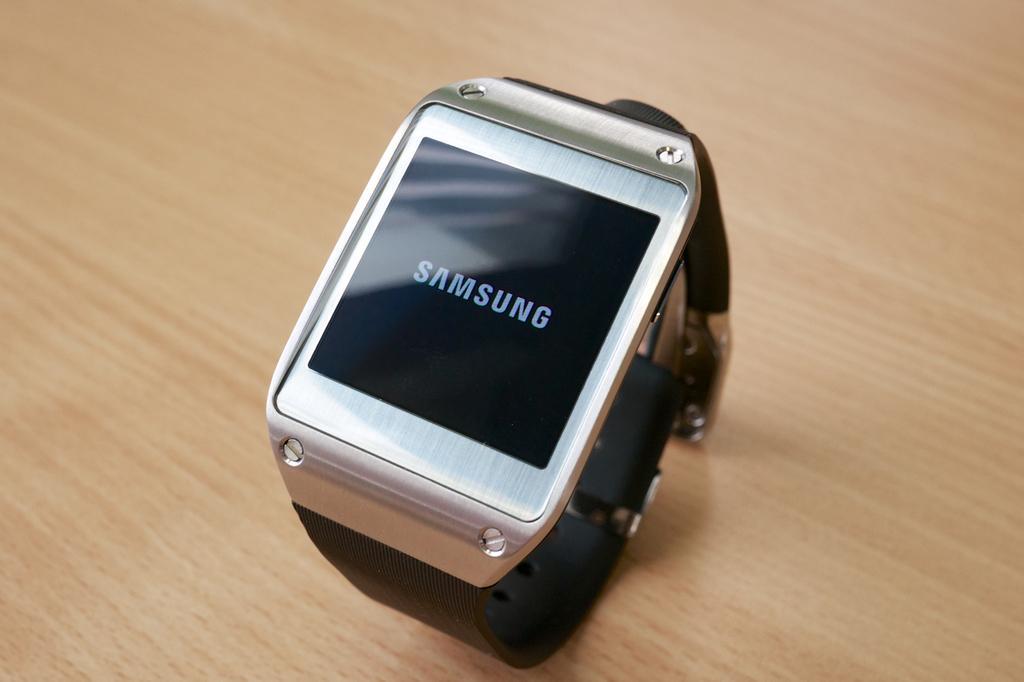Please provide a concise description of this image. In this picture we can see a Samsung device on the table. 